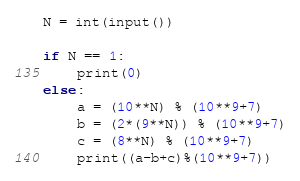Convert code to text. <code><loc_0><loc_0><loc_500><loc_500><_Python_>N = int(input())

if N == 1:
    print(0)
else:
    a = (10**N) % (10**9+7)
    b = (2*(9**N)) % (10**9+7)
    c = (8**N) % (10**9+7)
    print((a-b+c)%(10**9+7))</code> 